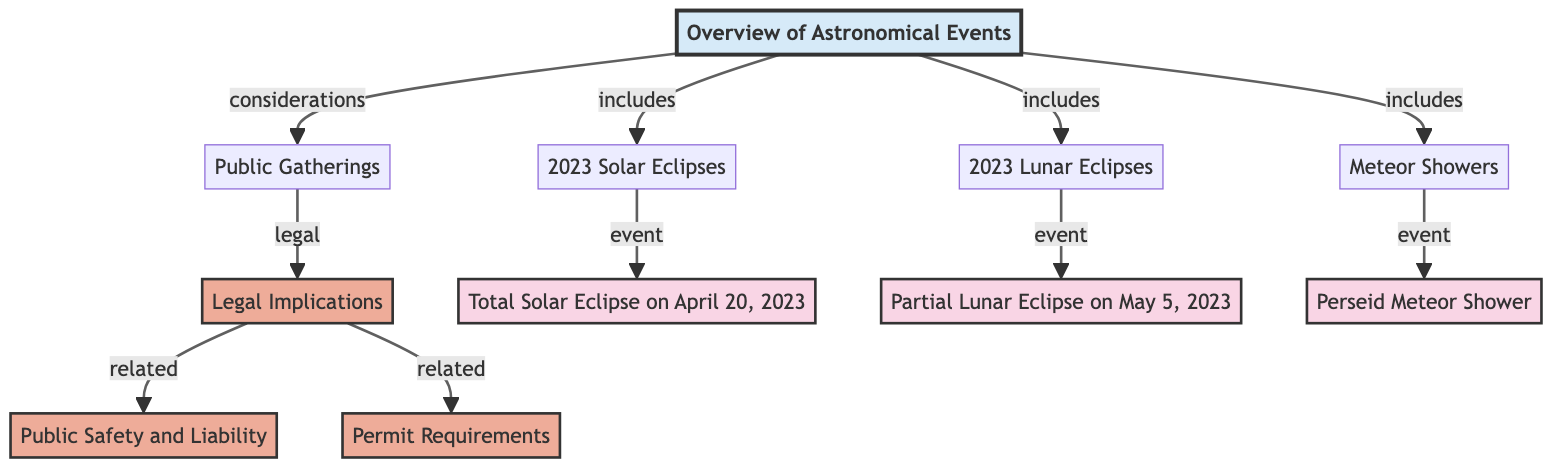What are the types of astronomical events included in the overview? The overview includes Solar Eclipses, Lunar Eclipses, and Meteor Showers, which are listed as nodes branching from the main overview node.
Answer: Solar Eclipses, Lunar Eclipses, Meteor Showers What is the date of the Total Solar Eclipse? The Total Solar Eclipse is specifically noted as happening on April 20, 2023. This can be found as a child node under the Solar Eclipses section.
Answer: April 20, 2023 How many legal implications are associated with public gatherings? There are two legal implications listed under the Public Gatherings node: Public Safety and Liability, and Permit Requirements.
Answer: 2 Which event occurs on May 5, 2023? The diagram specifies a Partial Lunar Eclipse happening on May 5, 2023, which is noted as a child node under the Lunar Eclipses section.
Answer: Partial Lunar Eclipse What are the legal considerations related to public gatherings? The legal implications linked with public gatherings include Public Safety and Liability and Permit Requirements. These are shown as nodes connected to the Legal Implications node.
Answer: Public Safety and Liability, Permit Requirements How many total events are shown in the diagram? The diagram has three main types of events: Total Solar Eclipse, Partial Lunar Eclipse, and the Perseid Meteor Shower, totaling three events.
Answer: 3 What is the first event listed in the diagram? The first event listed is the Total Solar Eclipse, which appears at the top under Solar Eclipses, indicating its precedence in the timeline of events.
Answer: Total Solar Eclipse What relationship is shown between public gatherings and legal implications? Public gatherings are connected directly to legal implications in the diagram, indicating that gatherings require consideration of legal aspects, as illustrated by the directed arrows.
Answer: Considerations How many nodes represent events in the diagram? The diagram includes three event nodes representing a Total Solar Eclipse, a Partial Lunar Eclipse, and a meteor shower, resulting in three event nodes.
Answer: 3 